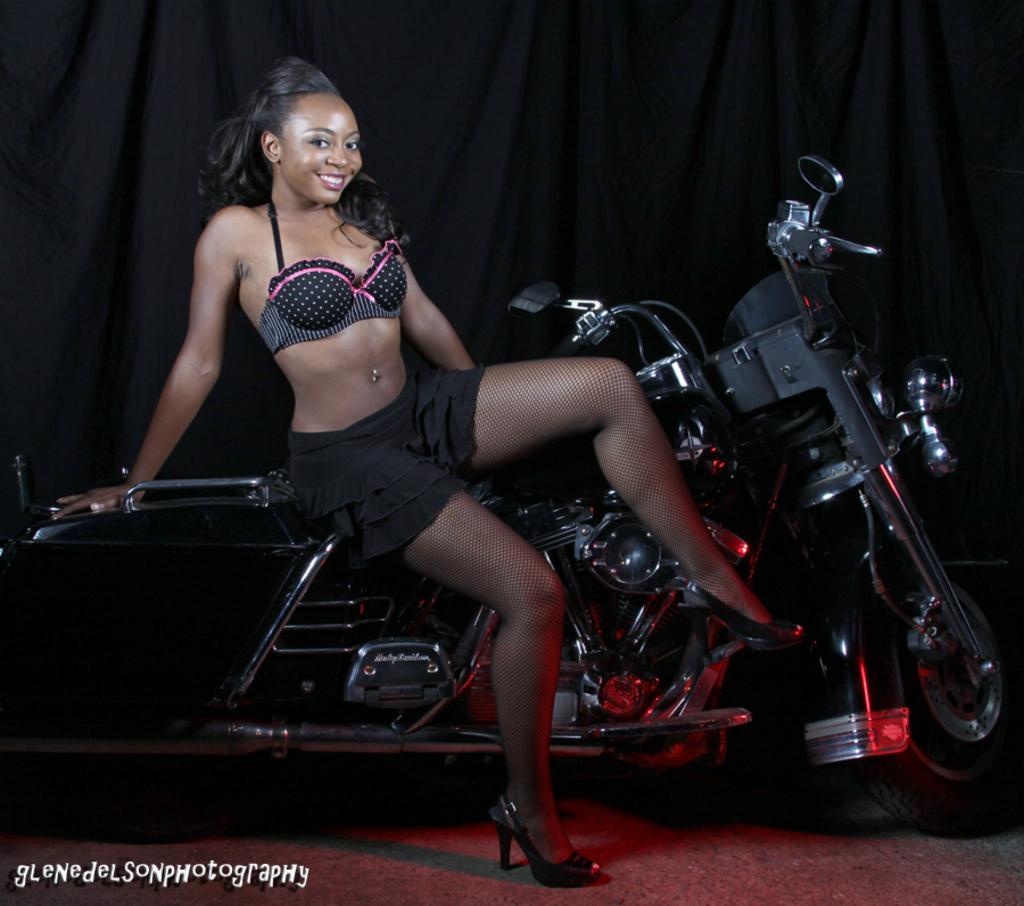Who is the main subject in the picture? There is a woman in the picture. What is the woman doing in the image? The woman is sitting on a bike. What type of spiders can be seen crawling on the grass in the image? There is no grass or spiders present in the image; it features a woman sitting on a bike. 